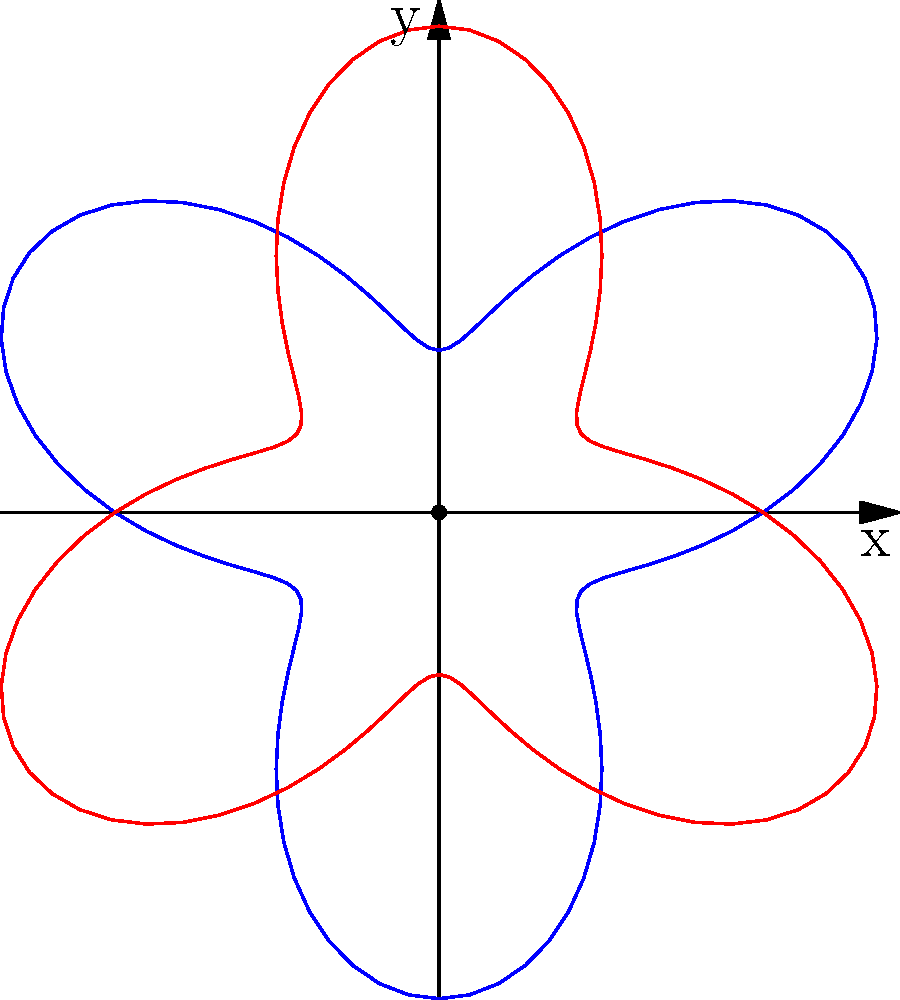In the context of art therapy, a symmetrical design is created using polar coordinates to represent healing and transformation. The blue curve is given by the equation $r = 2 + \sin(3\theta)$ for $0 \leq \theta \leq 2\pi$. What is the area enclosed by both the blue and red curves combined? To find the area enclosed by both curves, we can follow these steps:

1) The area of a single curve in polar coordinates is given by the formula:

   $A = \frac{1}{2} \int_{0}^{2\pi} r^2(\theta) d\theta$

2) For our curve, $r(\theta) = 2 + \sin(3\theta)$

3) We need to square this function:

   $r^2(\theta) = (2 + \sin(3\theta))^2 = 4 + 4\sin(3\theta) + \sin^2(3\theta)$

4) Now, we integrate this function:

   $A = \frac{1}{2} \int_{0}^{2\pi} (4 + 4\sin(3\theta) + \sin^2(3\theta)) d\theta$

5) Integrate each term:
   
   $\int_{0}^{2\pi} 4 d\theta = 4\theta |_{0}^{2\pi} = 8\pi$
   
   $\int_{0}^{2\pi} 4\sin(3\theta) d\theta = -\frac{4}{3}\cos(3\theta) |_{0}^{2\pi} = 0$
   
   $\int_{0}^{2\pi} \sin^2(3\theta) d\theta = \int_{0}^{2\pi} \frac{1-\cos(6\theta)}{2} d\theta = \pi - 0 = \pi$

6) Sum up the results:

   $A = \frac{1}{2} (8\pi + 0 + \pi) = \frac{9\pi}{2}$

7) Since the design is symmetrical and includes two identical curves, we multiply this result by 2:

   $A_{total} = 2 \cdot \frac{9\pi}{2} = 9\pi$

Therefore, the total area enclosed by both curves is $9\pi$ square units.
Answer: $9\pi$ square units 